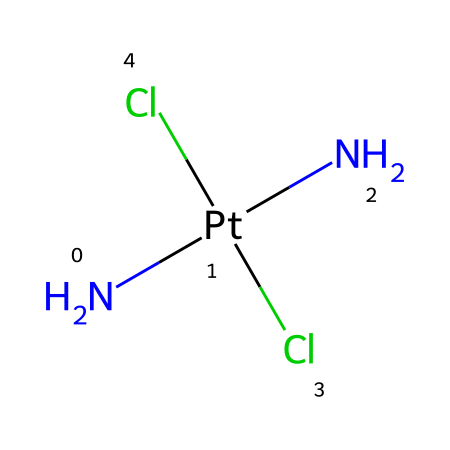What is the central metal atom in this chemical structure? The chemical structure shows a platinum (Pt) atom at the center, indicated by the presence of 'Pt' in the SMILES notation.
Answer: platinum How many chloride ions are present in the chemical composition? The SMILES representation shows two 'Cl' atoms, denoting two chloride ions attached to the central platinum atom.
Answer: two What type of bonding is primarily observed in this organometallic compound? The structure includes coordination bonds where nitrogen atoms (N) and chloride ions (Cl) are bonded to the central platinum atom, indicating coordinate covalent bonding.
Answer: coordinate covalent What is the total number of nitrogen atoms in this compound? The SMILES notation includes two 'N' atoms in the structure, which indicates the presence of two nitrogen atoms in cisplatin.
Answer: two How many ligands are attached to the central platinum atom? The chemical structure displays a total of four ligands: two nitrogen atoms and two chloride ions, which all coordinate to the platinum.
Answer: four What is the oxidation state of the central platinum atom in this compound? The coordination of two neutral amine groups (N) and two chlorides (Cl) suggests that the oxidation state of platinum in cisplatin is +2.
Answer: +2 